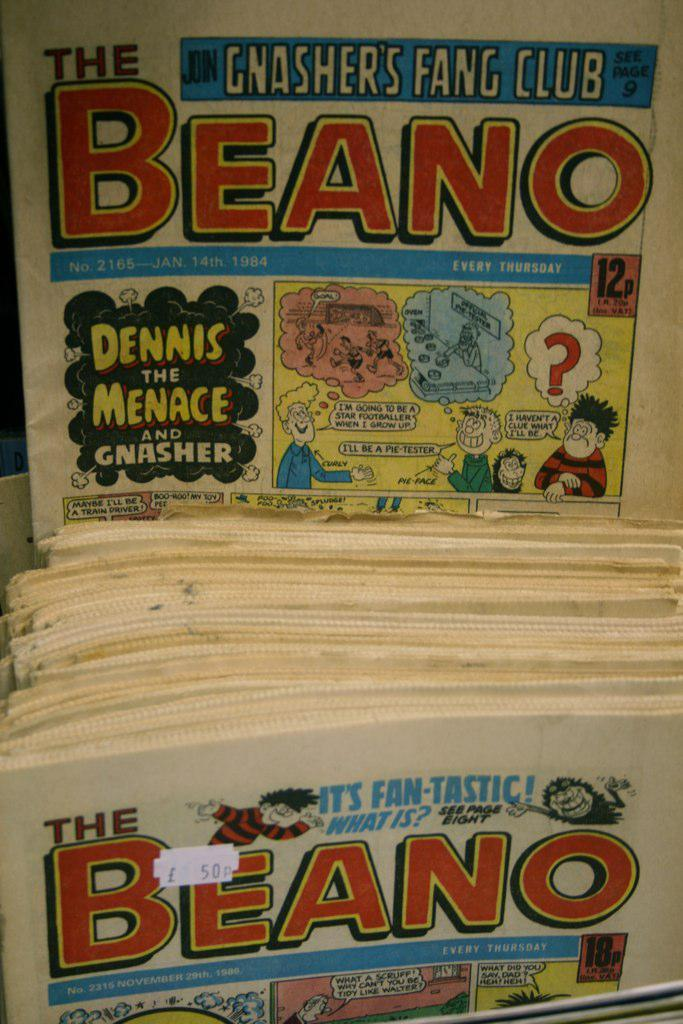Provide a one-sentence caption for the provided image. Stacks of a comic magazine with the name Beano on the front. 